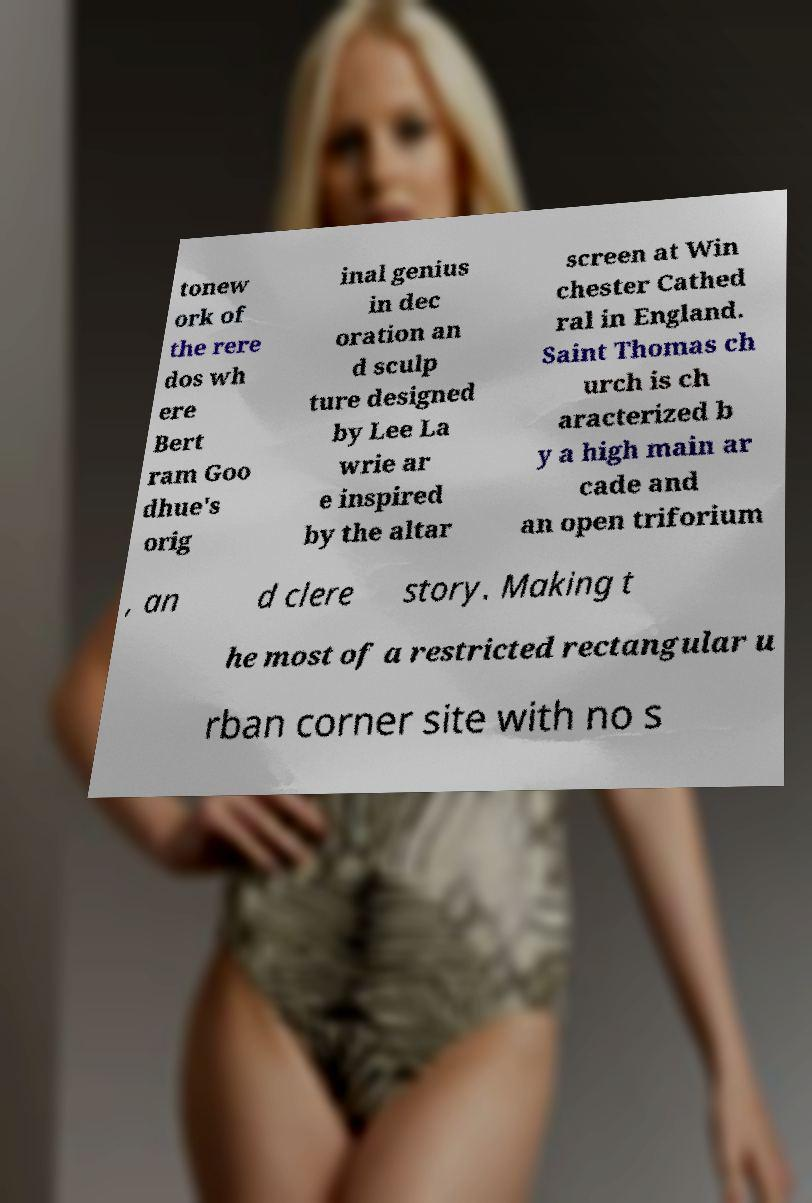Please read and relay the text visible in this image. What does it say? tonew ork of the rere dos wh ere Bert ram Goo dhue's orig inal genius in dec oration an d sculp ture designed by Lee La wrie ar e inspired by the altar screen at Win chester Cathed ral in England. Saint Thomas ch urch is ch aracterized b y a high main ar cade and an open triforium , an d clere story. Making t he most of a restricted rectangular u rban corner site with no s 